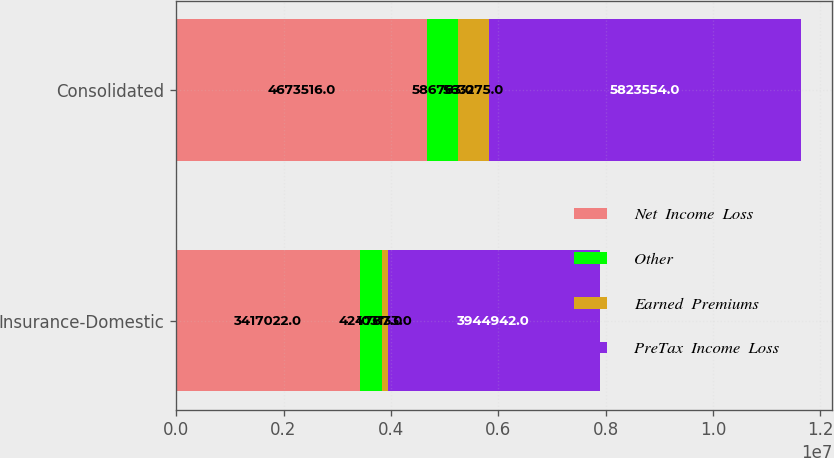Convert chart. <chart><loc_0><loc_0><loc_500><loc_500><stacked_bar_chart><ecel><fcel>Insurance-Domestic<fcel>Consolidated<nl><fcel>Net  Income  Loss<fcel>3.41702e+06<fcel>4.67352e+06<nl><fcel>Other<fcel>424787<fcel>586763<nl><fcel>Earned  Premiums<fcel>103133<fcel>563275<nl><fcel>PreTax  Income  Loss<fcel>3.94494e+06<fcel>5.82355e+06<nl></chart> 